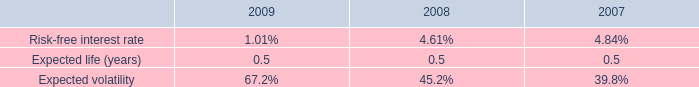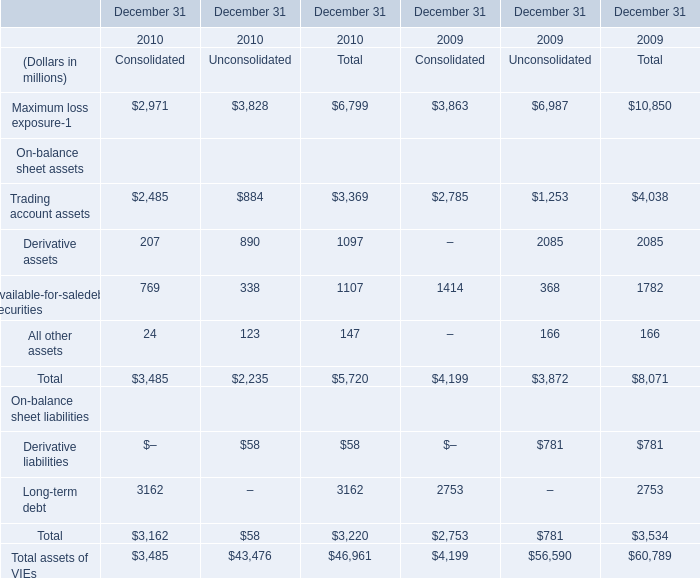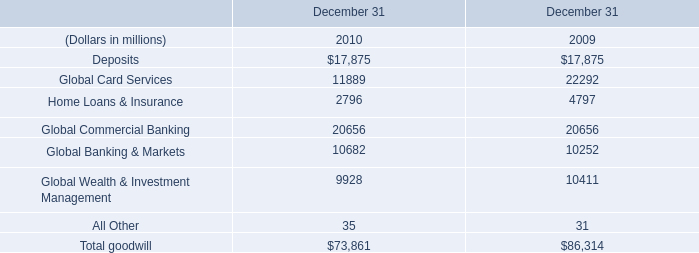What's the average of Trading account assets of consolidated in 2010 and 2009? (in millions) 
Computations: ((2485 + 2785) / 2)
Answer: 2635.0. 